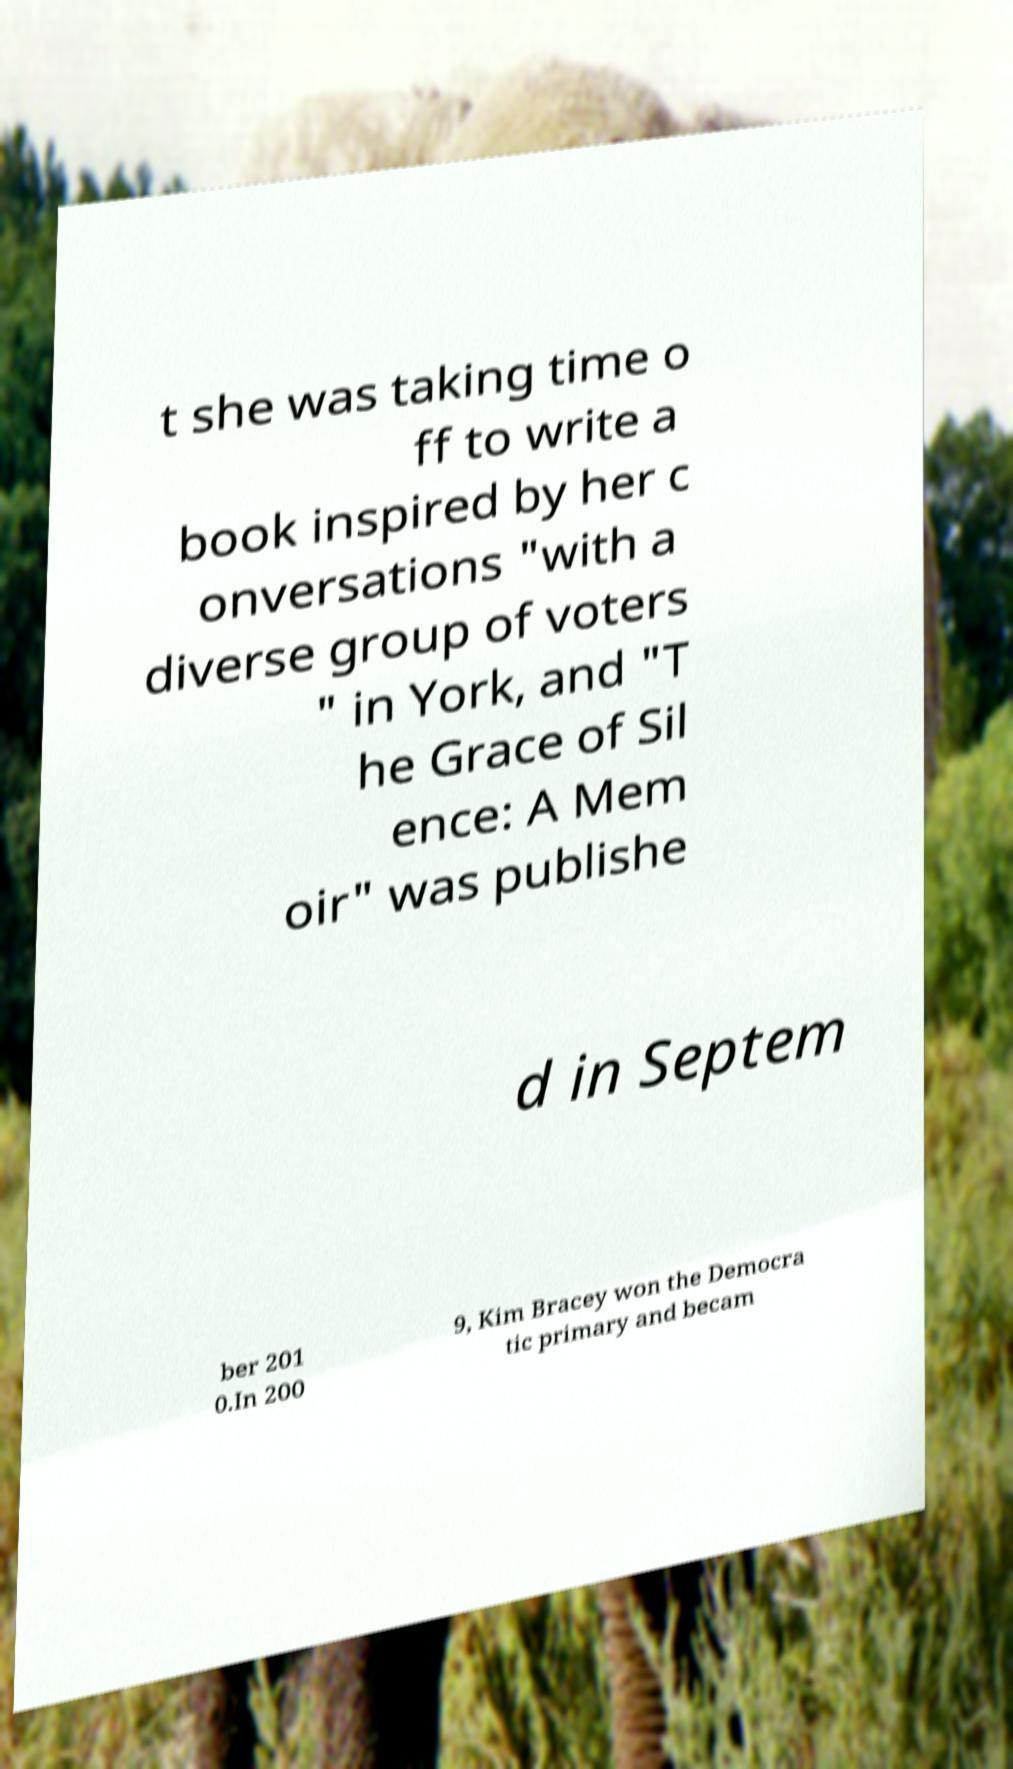Could you assist in decoding the text presented in this image and type it out clearly? t she was taking time o ff to write a book inspired by her c onversations "with a diverse group of voters " in York, and "T he Grace of Sil ence: A Mem oir" was publishe d in Septem ber 201 0.In 200 9, Kim Bracey won the Democra tic primary and becam 